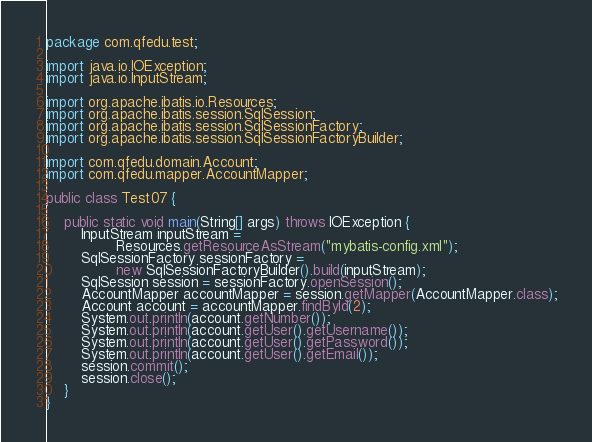<code> <loc_0><loc_0><loc_500><loc_500><_Java_>package com.qfedu.test;

import java.io.IOException;
import java.io.InputStream;

import org.apache.ibatis.io.Resources;
import org.apache.ibatis.session.SqlSession;
import org.apache.ibatis.session.SqlSessionFactory;
import org.apache.ibatis.session.SqlSessionFactoryBuilder;

import com.qfedu.domain.Account;
import com.qfedu.mapper.AccountMapper;

public class Test07 {

	public static void main(String[] args) throws IOException {
		InputStream inputStream = 
				Resources.getResourceAsStream("mybatis-config.xml");
		SqlSessionFactory sessionFactory = 
				new SqlSessionFactoryBuilder().build(inputStream);
		SqlSession session = sessionFactory.openSession();
		AccountMapper accountMapper = session.getMapper(AccountMapper.class);
		Account account = accountMapper.findById(2);
		System.out.println(account.getNumber());
		System.out.println(account.getUser().getUsername());
		System.out.println(account.getUser().getPassword());
		System.out.println(account.getUser().getEmail());
		session.commit();
		session.close();
	}
}
</code> 